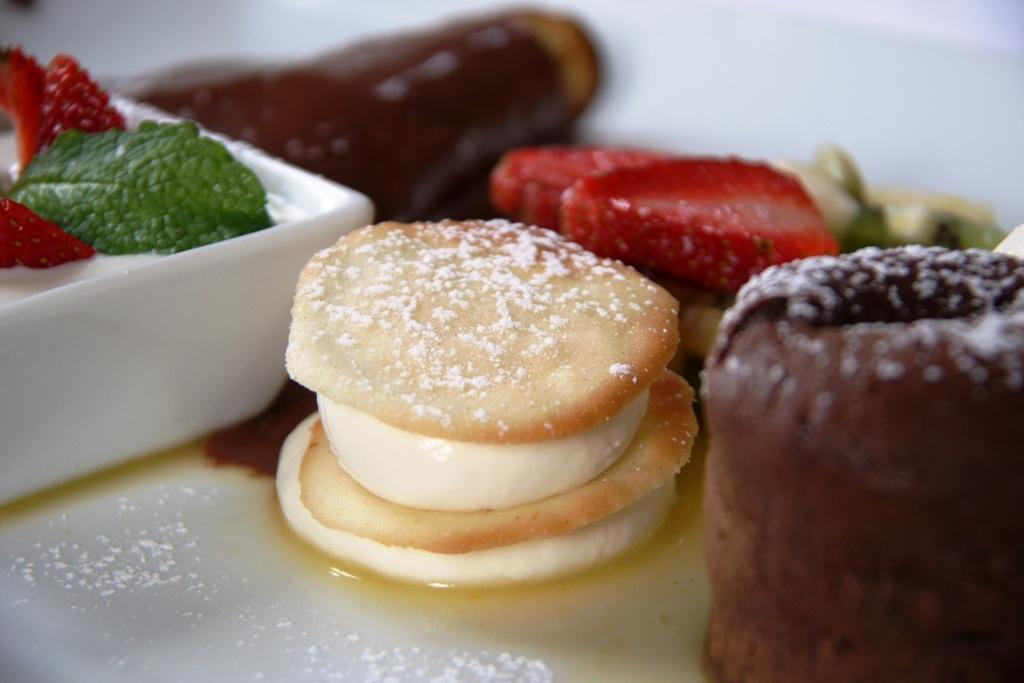Describe this image in one or two sentences. In this picture I can see food items and white color bowl on a white color plate. 